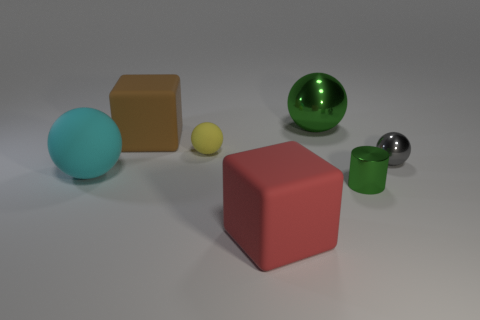Add 2 cyan metal spheres. How many objects exist? 9 Subtract all spheres. How many objects are left? 3 Add 5 yellow spheres. How many yellow spheres exist? 6 Subtract 1 green cylinders. How many objects are left? 6 Subtract all blue metallic cylinders. Subtract all large cubes. How many objects are left? 5 Add 4 large green spheres. How many large green spheres are left? 5 